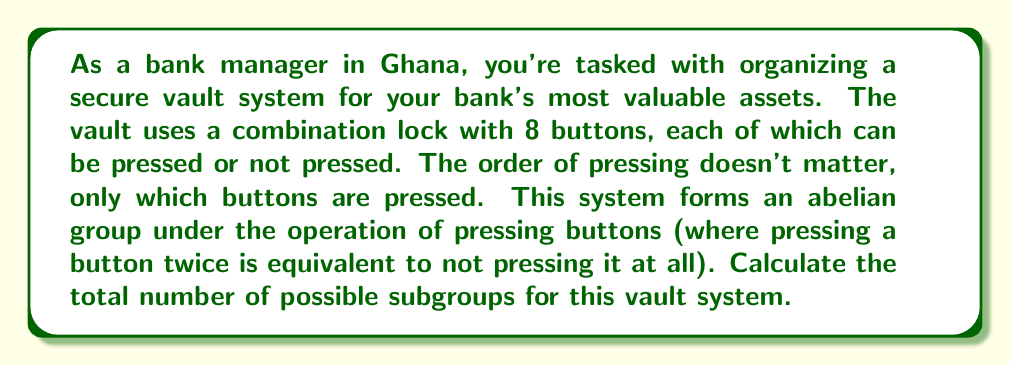Help me with this question. Let's approach this step-by-step:

1) First, we need to recognize that this system forms an abelian group isomorphic to $(\mathbb{Z}_2)^8$, as each button has two states (pressed or not pressed) and the order doesn't matter.

2) The number of subgroups in $(\mathbb{Z}_2)^n$ is given by the Gaussian binomial coefficient $\sum_{k=0}^n \prod_{i=0}^{k-1} \frac{2^n - 2^i}{2^k - 2^i}$.

3) In our case, $n = 8$. So we need to calculate:

   $$\sum_{k=0}^8 \prod_{i=0}^{k-1} \frac{2^8 - 2^i}{2^k - 2^i}$$

4) Let's calculate this sum term by term:

   For $k = 0$: 1
   For $k = 1$: $(2^8 - 1)/(2^1 - 1) = 255$
   For $k = 2$: $(2^8 - 1)(2^8 - 2)/(2^2 - 1)(2^2 - 2) = 5,355$
   For $k = 3$: $(2^8 - 1)(2^8 - 2)(2^8 - 4)/(2^3 - 1)(2^3 - 2)(2^3 - 4) = 41,665$
   For $k = 4$: $(2^8 - 1)(2^8 - 2)(2^8 - 4)(2^8 - 8)/(2^4 - 1)(2^4 - 2)(2^4 - 4)(2^4 - 8) = 127,905$
   For $k = 5$: 151,473
   For $k = 6$: 67,425
   For $k = 7$: 10,795
   For $k = 8$: 255

5) Sum all these terms: 1 + 255 + 5,355 + 41,665 + 127,905 + 151,473 + 67,425 + 10,795 + 255 = 405,129

Therefore, the total number of possible subgroups for this vault system is 405,129.
Answer: 405,129 